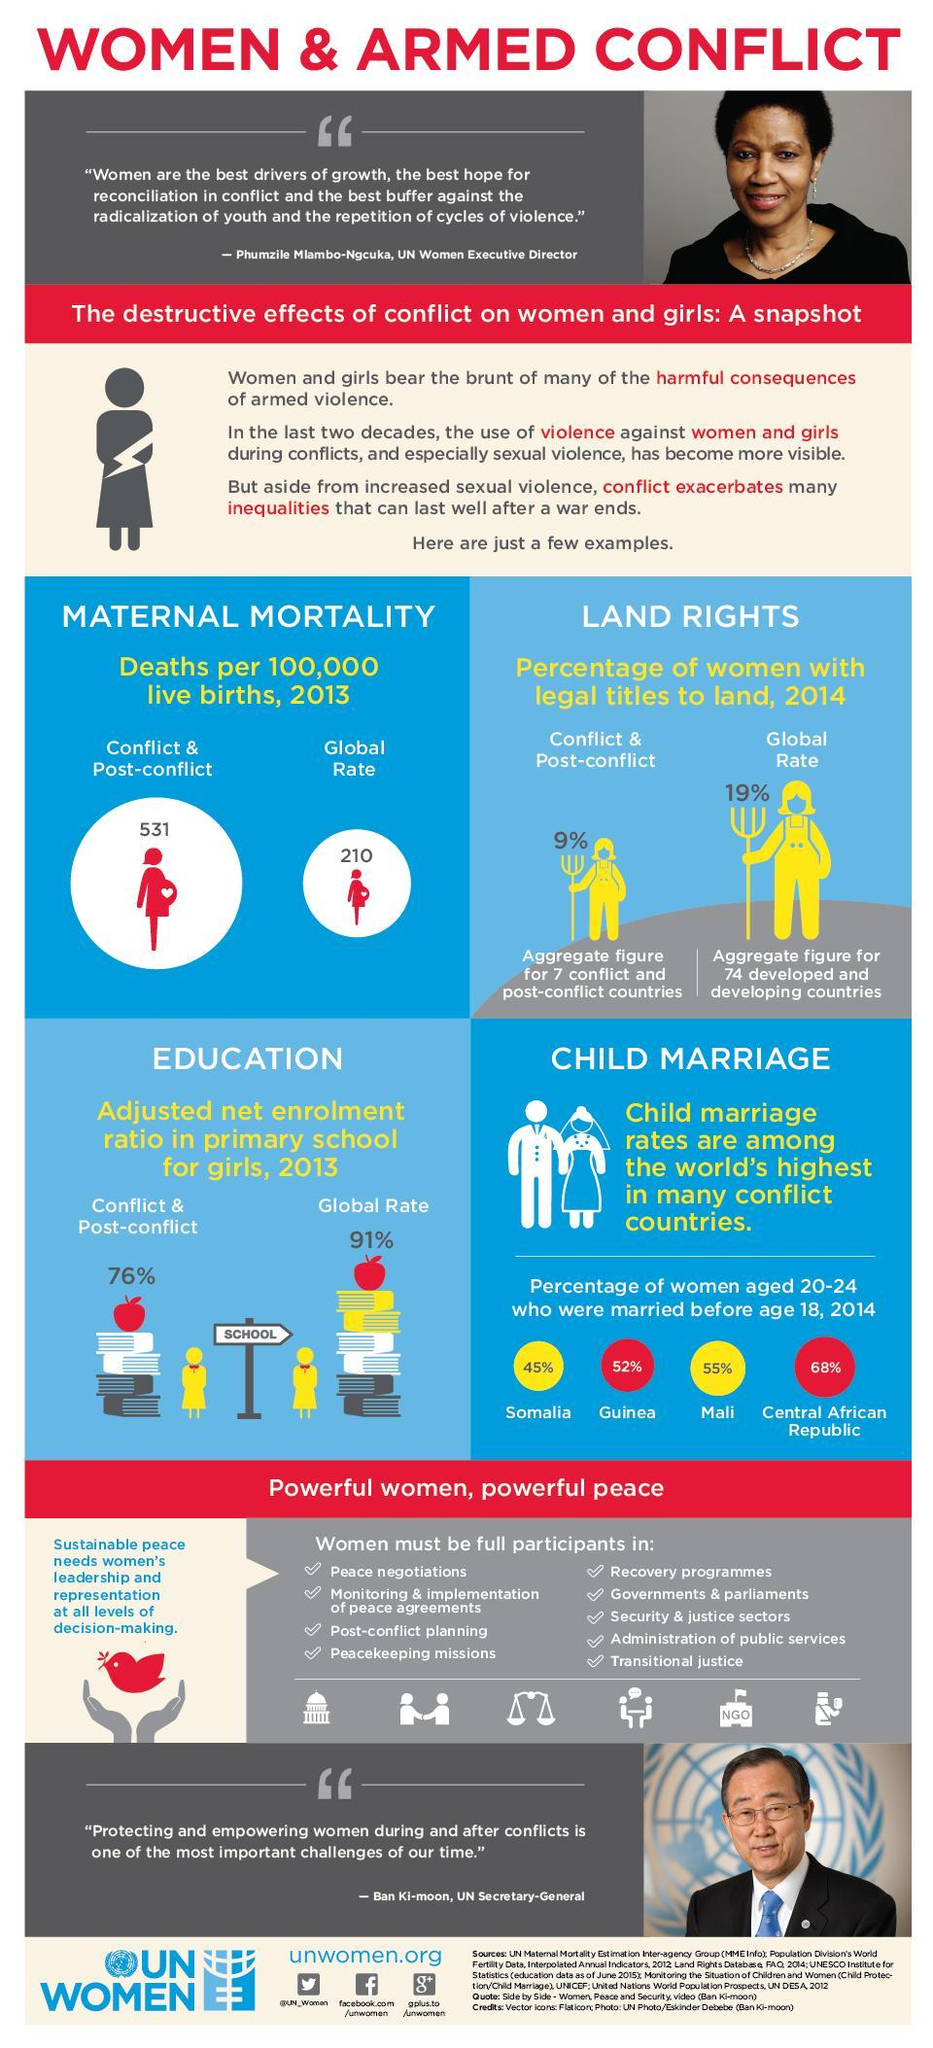What is the percentage of women who married before 18 in Somalia and Mali, taken together?
Answer the question with a short phrase. 100% What is the percentage of women who married before 18 in Somalia and Guinea, taken together? 97% 